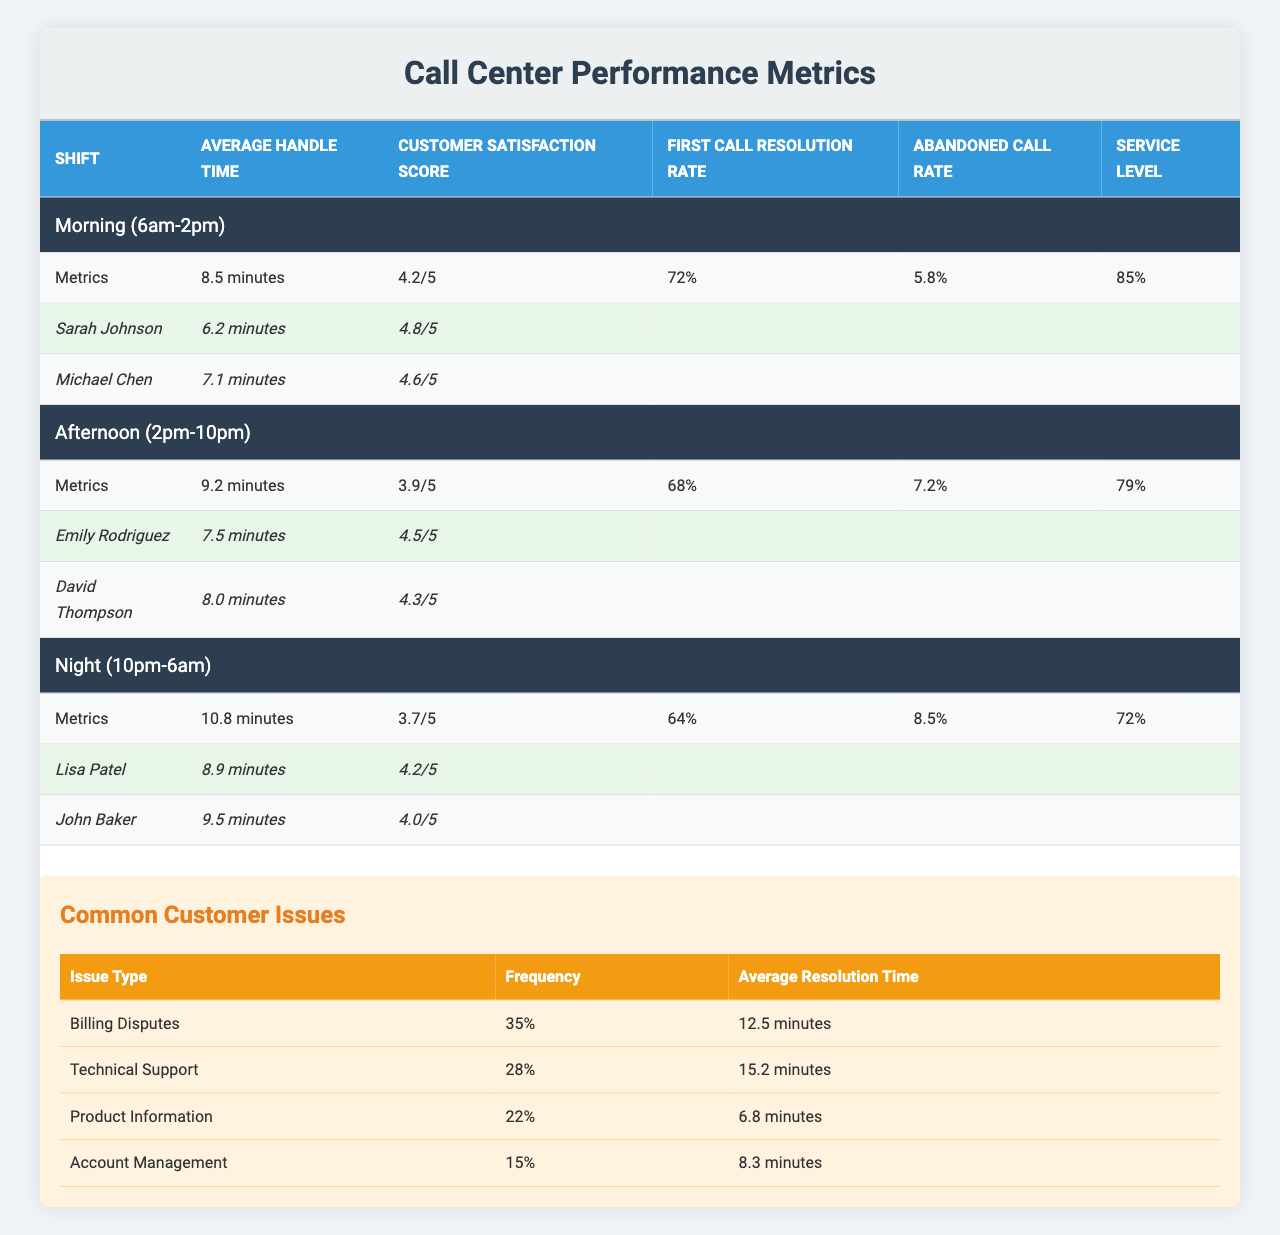What is the average handle time during the Morning shift? According to the table, the Average Handle Time for the Morning shift is listed as 8.5 minutes.
Answer: 8.5 minutes Which shift has the highest customer satisfaction score? By comparing the Customer Satisfaction Scores of each shift, the Morning shift has a score of 4.2/5, the Afternoon shift is 3.9/5, and the Night shift is 3.7/5. Therefore, the Morning shift has the highest score.
Answer: Morning shift What is the abandoned call rate for the Night shift? The table shows that the Abandoned Call Rate for the Night shift is 8.5%.
Answer: 8.5% What percentage of calls are resolved on the first call during the Afternoon shift? The table indicates that the First Call Resolution Rate for the Afternoon shift is 68%.
Answer: 68% Which top performer has the lowest average handle time during the Morning shift? The Morning shift has two top performers: Sarah Johnson with 6.2 minutes and Michael Chen with 7.1 minutes. Therefore, Sarah Johnson has the lowest handle time.
Answer: Sarah Johnson Calculate the average customer satisfaction score for all shifts. The Customer Satisfaction Scores are 4.2/5, 3.9/5, and 3.7/5. Adding them gives 4.2 + 3.9 + 3.7 = 11.8. There are 3 scores, so the average is 11.8 / 3 = 3.93.
Answer: 3.93 Is there a top performer with an average handle time less than 7 minutes in the Afternoon shift? In the Afternoon shift, Emily Rodriguez has 7.5 minutes and David Thompson has 8.0 minutes. Neither has an average handle time less than 7 minutes. Therefore, the answer is no.
Answer: No Which shift has the lowest service level? The service levels are 85% for Morning, 79% for Afternoon, and 72% for Night. The lowest is 72% for the Night shift.
Answer: Night shift What is the average resolution time for Technical Support issues? The table lists the Average Resolution Time for Technical Support issues as 15.2 minutes.
Answer: 15.2 minutes Count the total percentage of common customer issues related to billing and technical support combined. Billing Disputes account for 35% of the issues, and Technical Support accounts for 28%. Summing these gives 35% + 28% = 63%.
Answer: 63% 